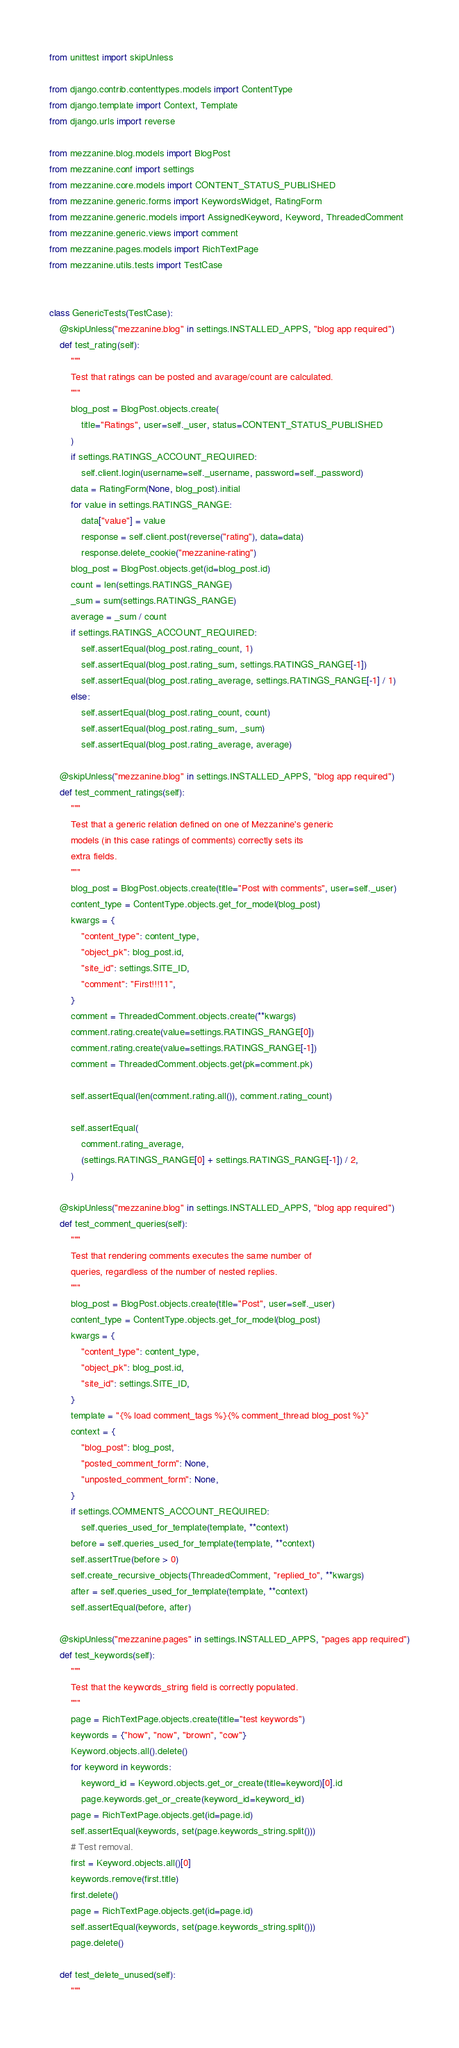<code> <loc_0><loc_0><loc_500><loc_500><_Python_>from unittest import skipUnless

from django.contrib.contenttypes.models import ContentType
from django.template import Context, Template
from django.urls import reverse

from mezzanine.blog.models import BlogPost
from mezzanine.conf import settings
from mezzanine.core.models import CONTENT_STATUS_PUBLISHED
from mezzanine.generic.forms import KeywordsWidget, RatingForm
from mezzanine.generic.models import AssignedKeyword, Keyword, ThreadedComment
from mezzanine.generic.views import comment
from mezzanine.pages.models import RichTextPage
from mezzanine.utils.tests import TestCase


class GenericTests(TestCase):
    @skipUnless("mezzanine.blog" in settings.INSTALLED_APPS, "blog app required")
    def test_rating(self):
        """
        Test that ratings can be posted and avarage/count are calculated.
        """
        blog_post = BlogPost.objects.create(
            title="Ratings", user=self._user, status=CONTENT_STATUS_PUBLISHED
        )
        if settings.RATINGS_ACCOUNT_REQUIRED:
            self.client.login(username=self._username, password=self._password)
        data = RatingForm(None, blog_post).initial
        for value in settings.RATINGS_RANGE:
            data["value"] = value
            response = self.client.post(reverse("rating"), data=data)
            response.delete_cookie("mezzanine-rating")
        blog_post = BlogPost.objects.get(id=blog_post.id)
        count = len(settings.RATINGS_RANGE)
        _sum = sum(settings.RATINGS_RANGE)
        average = _sum / count
        if settings.RATINGS_ACCOUNT_REQUIRED:
            self.assertEqual(blog_post.rating_count, 1)
            self.assertEqual(blog_post.rating_sum, settings.RATINGS_RANGE[-1])
            self.assertEqual(blog_post.rating_average, settings.RATINGS_RANGE[-1] / 1)
        else:
            self.assertEqual(blog_post.rating_count, count)
            self.assertEqual(blog_post.rating_sum, _sum)
            self.assertEqual(blog_post.rating_average, average)

    @skipUnless("mezzanine.blog" in settings.INSTALLED_APPS, "blog app required")
    def test_comment_ratings(self):
        """
        Test that a generic relation defined on one of Mezzanine's generic
        models (in this case ratings of comments) correctly sets its
        extra fields.
        """
        blog_post = BlogPost.objects.create(title="Post with comments", user=self._user)
        content_type = ContentType.objects.get_for_model(blog_post)
        kwargs = {
            "content_type": content_type,
            "object_pk": blog_post.id,
            "site_id": settings.SITE_ID,
            "comment": "First!!!11",
        }
        comment = ThreadedComment.objects.create(**kwargs)
        comment.rating.create(value=settings.RATINGS_RANGE[0])
        comment.rating.create(value=settings.RATINGS_RANGE[-1])
        comment = ThreadedComment.objects.get(pk=comment.pk)

        self.assertEqual(len(comment.rating.all()), comment.rating_count)

        self.assertEqual(
            comment.rating_average,
            (settings.RATINGS_RANGE[0] + settings.RATINGS_RANGE[-1]) / 2,
        )

    @skipUnless("mezzanine.blog" in settings.INSTALLED_APPS, "blog app required")
    def test_comment_queries(self):
        """
        Test that rendering comments executes the same number of
        queries, regardless of the number of nested replies.
        """
        blog_post = BlogPost.objects.create(title="Post", user=self._user)
        content_type = ContentType.objects.get_for_model(blog_post)
        kwargs = {
            "content_type": content_type,
            "object_pk": blog_post.id,
            "site_id": settings.SITE_ID,
        }
        template = "{% load comment_tags %}{% comment_thread blog_post %}"
        context = {
            "blog_post": blog_post,
            "posted_comment_form": None,
            "unposted_comment_form": None,
        }
        if settings.COMMENTS_ACCOUNT_REQUIRED:
            self.queries_used_for_template(template, **context)
        before = self.queries_used_for_template(template, **context)
        self.assertTrue(before > 0)
        self.create_recursive_objects(ThreadedComment, "replied_to", **kwargs)
        after = self.queries_used_for_template(template, **context)
        self.assertEqual(before, after)

    @skipUnless("mezzanine.pages" in settings.INSTALLED_APPS, "pages app required")
    def test_keywords(self):
        """
        Test that the keywords_string field is correctly populated.
        """
        page = RichTextPage.objects.create(title="test keywords")
        keywords = {"how", "now", "brown", "cow"}
        Keyword.objects.all().delete()
        for keyword in keywords:
            keyword_id = Keyword.objects.get_or_create(title=keyword)[0].id
            page.keywords.get_or_create(keyword_id=keyword_id)
        page = RichTextPage.objects.get(id=page.id)
        self.assertEqual(keywords, set(page.keywords_string.split()))
        # Test removal.
        first = Keyword.objects.all()[0]
        keywords.remove(first.title)
        first.delete()
        page = RichTextPage.objects.get(id=page.id)
        self.assertEqual(keywords, set(page.keywords_string.split()))
        page.delete()

    def test_delete_unused(self):
        """</code> 